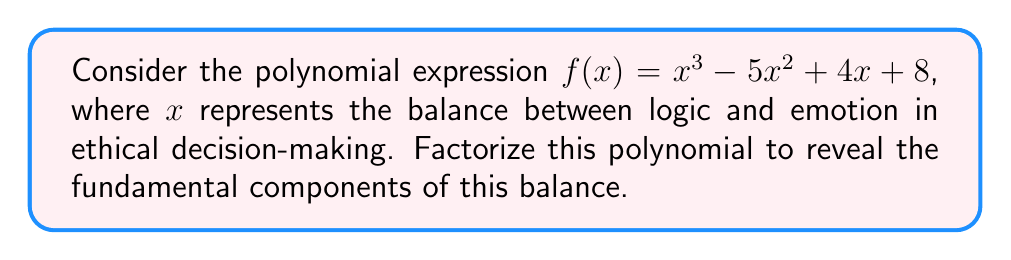Show me your answer to this math problem. To factorize this polynomial, we'll follow these steps:

1) First, let's check if there are any rational roots using the rational root theorem. The possible rational roots are the factors of the constant term: ±1, ±2, ±4, ±8.

2) Testing these values, we find that $x = 2$ is a root of the polynomial.

3) We can factor out $(x - 2)$:
   $f(x) = (x - 2)(x^2 + ax + b)$

4) To find $a$ and $b$, we can use polynomial long division or compare coefficients:
   $x^3 - 5x^2 + 4x + 8 = (x - 2)(x^2 + ax + b)$
   $x^3 - 5x^2 + 4x + 8 = x^3 + ax^2 + bx - 2x^2 - 2ax - 2b$

   Comparing coefficients:
   $a - 2 = -5$, so $a = -3$
   $b - 2a = 4$, so $b = -2$

5) Therefore, $f(x) = (x - 2)(x^2 - 3x - 2)$

6) The quadratic factor $x^2 - 3x - 2$ can be further factored:
   $(x - 4)(x + 1)$

7) Thus, the fully factored polynomial is:
   $f(x) = (x - 2)(x - 4)(x + 1)$

This factorization reveals three critical points in the balance of logic and emotion: $x = 2$, $x = 4$, and $x = -1$, representing different equilibrium states in ethical decision-making.
Answer: $(x - 2)(x - 4)(x + 1)$ 